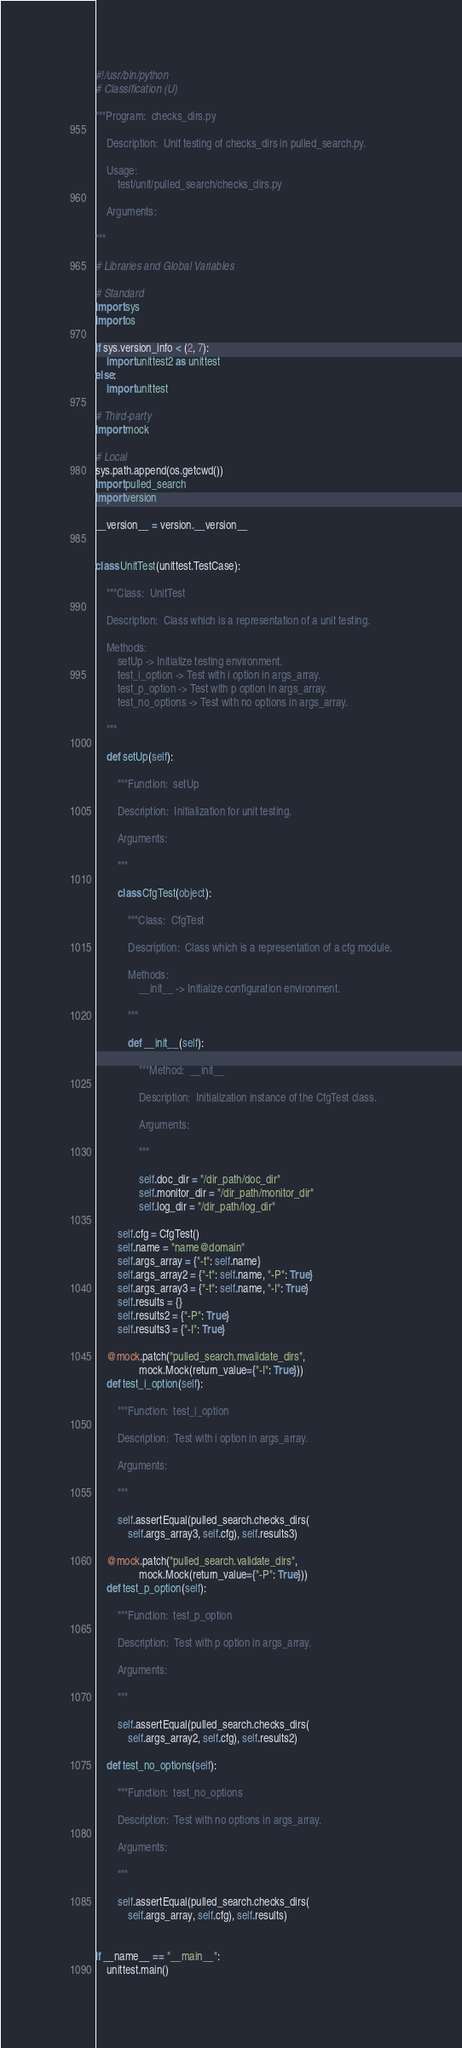Convert code to text. <code><loc_0><loc_0><loc_500><loc_500><_Python_>#!/usr/bin/python
# Classification (U)

"""Program:  checks_dirs.py

    Description:  Unit testing of checks_dirs in pulled_search.py.

    Usage:
        test/unit/pulled_search/checks_dirs.py

    Arguments:

"""

# Libraries and Global Variables

# Standard
import sys
import os

if sys.version_info < (2, 7):
    import unittest2 as unittest
else:
    import unittest

# Third-party
import mock

# Local
sys.path.append(os.getcwd())
import pulled_search
import version

__version__ = version.__version__


class UnitTest(unittest.TestCase):

    """Class:  UnitTest

    Description:  Class which is a representation of a unit testing.

    Methods:
        setUp -> Initialize testing environment.
        test_i_option -> Test with i option in args_array.
        test_p_option -> Test with p option in args_array.
        test_no_options -> Test with no options in args_array.

    """

    def setUp(self):

        """Function:  setUp

        Description:  Initialization for unit testing.

        Arguments:

        """

        class CfgTest(object):

            """Class:  CfgTest

            Description:  Class which is a representation of a cfg module.

            Methods:
                __init__ -> Initialize configuration environment.

            """

            def __init__(self):

                """Method:  __init__

                Description:  Initialization instance of the CfgTest class.

                Arguments:

                """

                self.doc_dir = "/dir_path/doc_dir"
                self.monitor_dir = "/dir_path/monitor_dir"
                self.log_dir = "/dir_path/log_dir"

        self.cfg = CfgTest()
        self.name = "name@domain"
        self.args_array = {"-t": self.name}
        self.args_array2 = {"-t": self.name, "-P": True}
        self.args_array3 = {"-t": self.name, "-I": True}
        self.results = {}
        self.results2 = {"-P": True}
        self.results3 = {"-I": True}

    @mock.patch("pulled_search.mvalidate_dirs",
                mock.Mock(return_value={"-I": True}))
    def test_i_option(self):

        """Function:  test_i_option

        Description:  Test with i option in args_array.

        Arguments:

        """

        self.assertEqual(pulled_search.checks_dirs(
            self.args_array3, self.cfg), self.results3)

    @mock.patch("pulled_search.validate_dirs",
                mock.Mock(return_value={"-P": True}))
    def test_p_option(self):

        """Function:  test_p_option

        Description:  Test with p option in args_array.

        Arguments:

        """

        self.assertEqual(pulled_search.checks_dirs(
            self.args_array2, self.cfg), self.results2)

    def test_no_options(self):

        """Function:  test_no_options

        Description:  Test with no options in args_array.

        Arguments:

        """

        self.assertEqual(pulled_search.checks_dirs(
            self.args_array, self.cfg), self.results)


if __name__ == "__main__":
    unittest.main()
</code> 